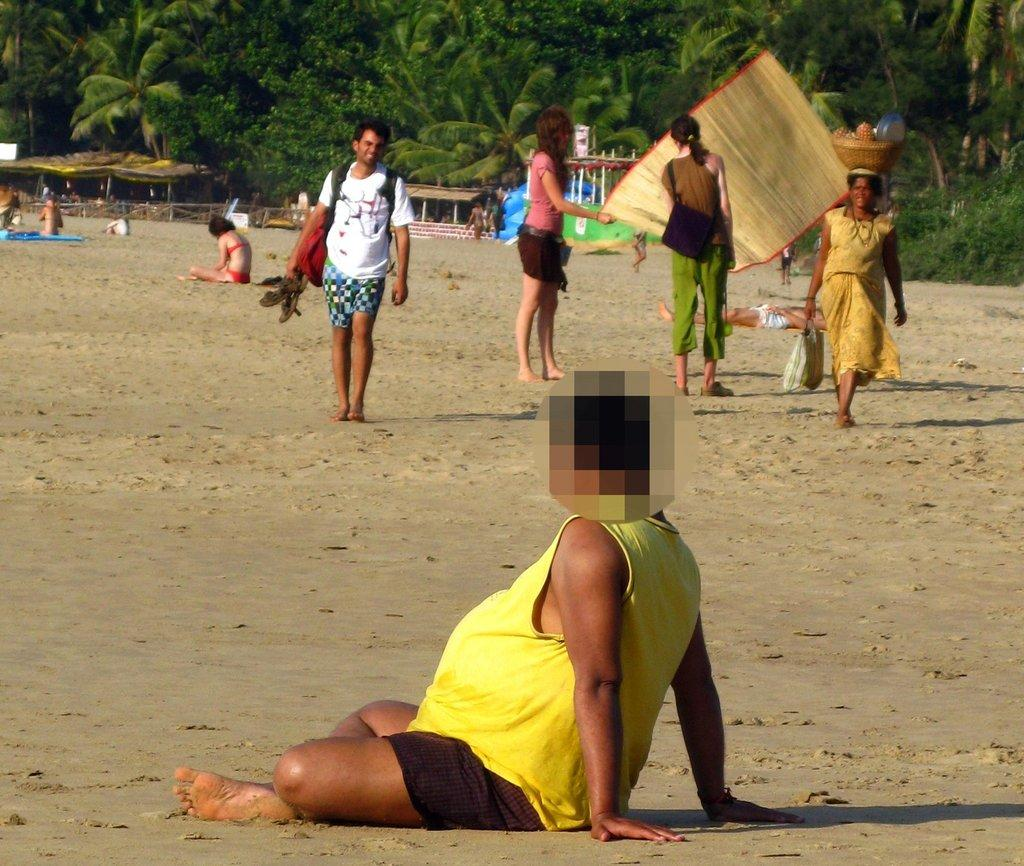Where are the people in the image located? The people are on sand in the image. What can be seen on the feet of the people in the image? Footwear is visible in the image. What items might the people be using to carry belongings? Bags are present in the image. What is placed on the ground for the people to sit or lie on? A mat is in the image. What container is visible in the image? A basket is in the image. What can be seen in the distance behind the people? Trees, shelters, and a fence are visible in the background of the image. What other unspecified objects can be seen in the background of the image? There are some unspecified objects in the background of the image. What type of wire is being used to support the stage in the image? There is no stage present in the image, so there is no wire supporting it. 